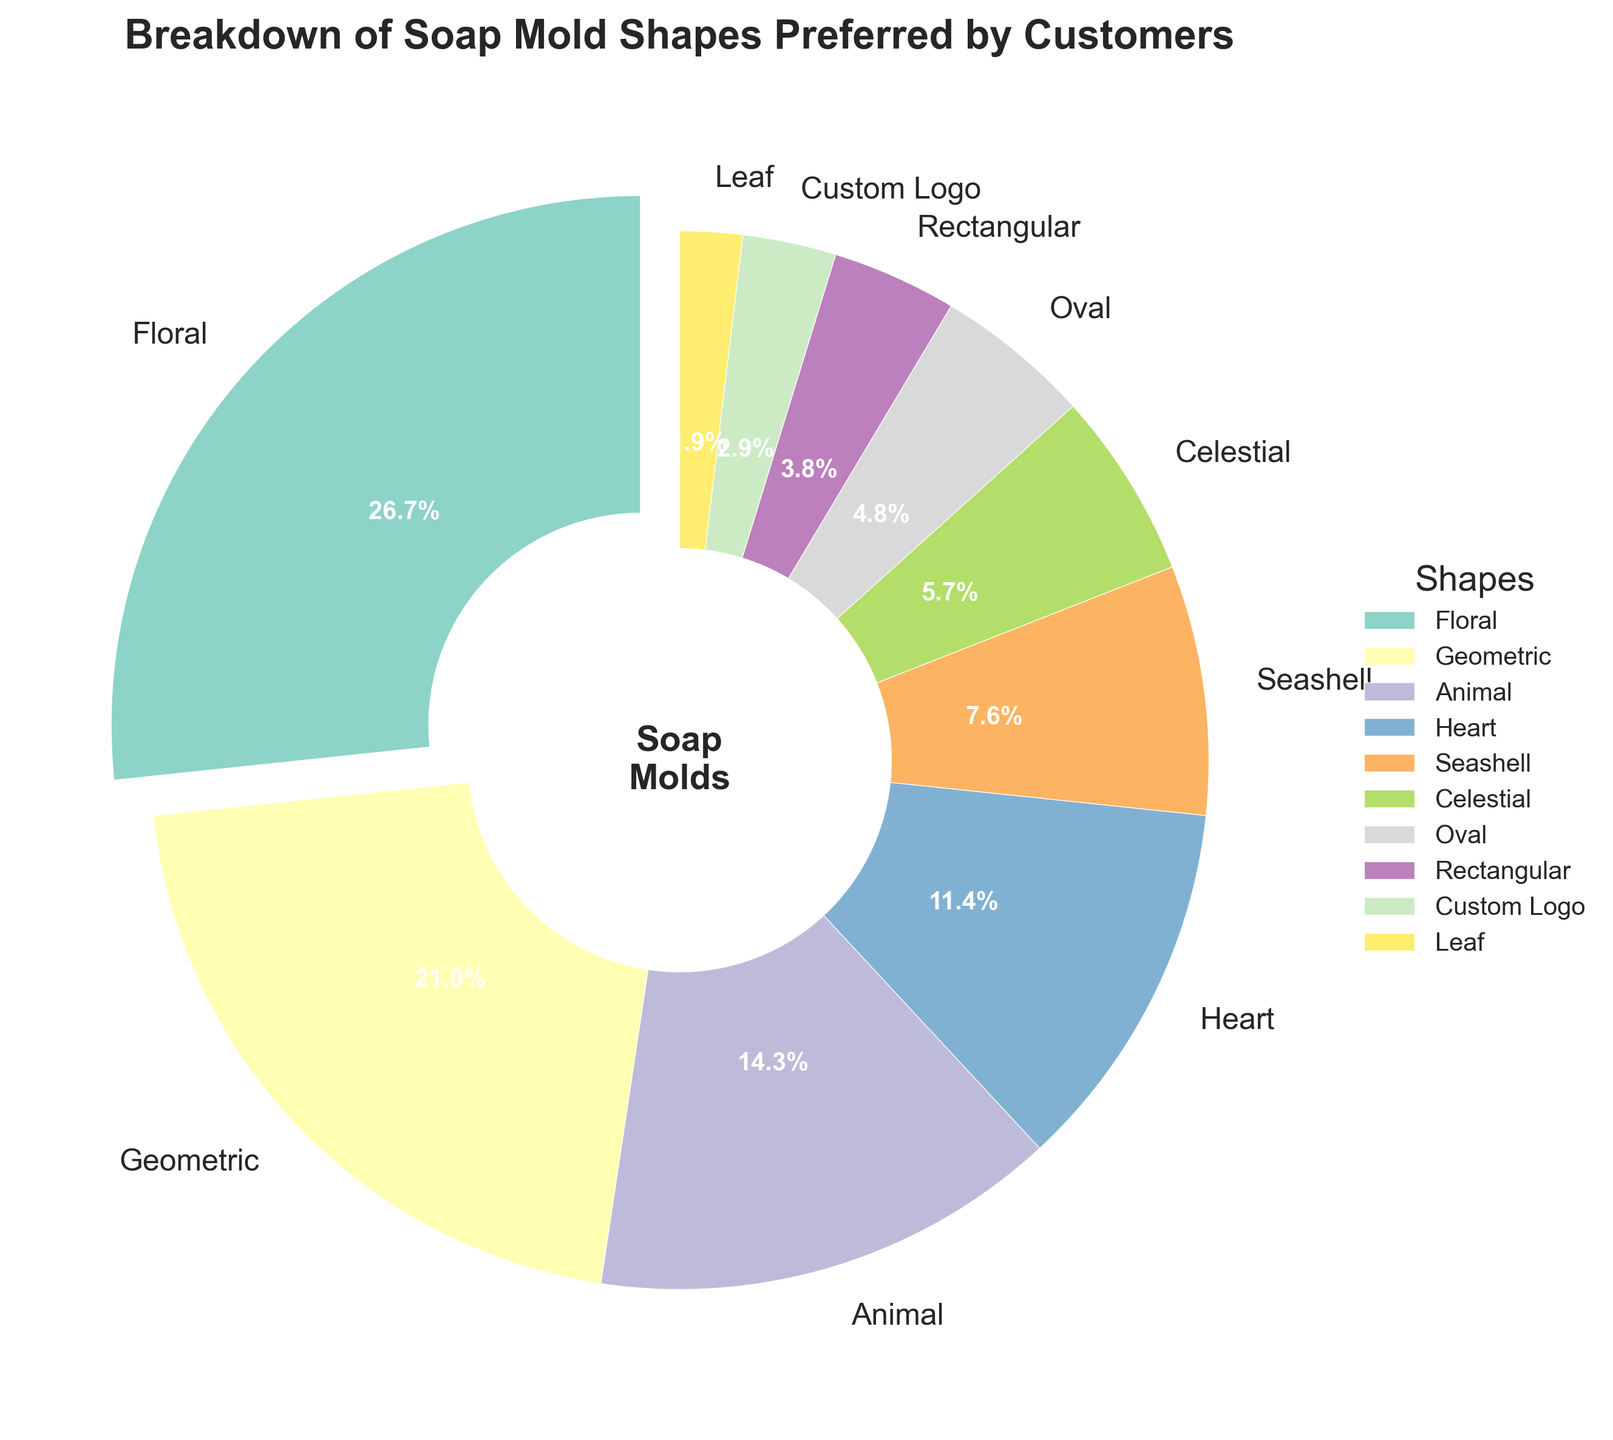Which soap mold shape is the most preferred by customers? The figure shows that the "Floral" shape has the largest slice of the pie chart, along with an exploded wedge for emphasis. This indicates it is the most preferred.
Answer: Floral Which two soap mold shapes have an equal percentage of preference? By observing the pie chart and the percentages, it's clear that no two shapes have exactly the same percentage of preference.
Answer: None Which mold shape category has a higher preference: Heart or Animal? The pie chart shows that "Animal" has a percentage of 15%, while "Heart" has a percentage of 12%. Therefore, "Animal" is more preferred.
Answer: Animal What is the combined percentage of the least three preferred soap mold shapes? According to the chart, the least three preferred shapes are "Rectangular" (4%), "Custom Logo" (3%), and "Leaf" (2%). Summing these up: 4% + 3% + 2% = 9%.
Answer: 9% How much more preferred is the "Celestial" shape compared to the "Oval" shape? The chart indicates that "Celestial" has a 6% preference and "Oval" has a 5% preference. The difference is 6% - 5% = 1%.
Answer: 1% What percentage of customers prefers geometric mold shapes? By looking at the pie chart, the "Geometric" shape is directly labeled with 22%.
Answer: 22% Which mold shape has the smallest preference and what is its percentage? The chart shows that "Leaf" is the smallest slice with a label of 2%.
Answer: Leaf, 2% Out of the four most preferred shapes, which one has the lowest percentage? The four most preferred shapes by percentage are "Floral" (28%), "Geometric" (22%), "Animal" (15%), and "Heart" (12%). "Heart" has the lowest among these.
Answer: Heart How does the preference for "Heart" shape compare to the total percentage of "Seashell" and "Oval" shapes combined? The "Heart" shape has a preference of 12%. "Seashell" has 8% and "Oval" has 5%. Combined, they have 8% + 5% = 13%. So, "Heart" has a 1% lower preference than the combined "Seashell" and "Oval".
Answer: 1% lower What's the visual color representation used for the "Custom Logo" soap mold shape? In the pie chart, the "Custom Logo" section is identified by a specific color. By looking at the legend, we can see the specific color assigned for "Custom Logo".
Answer: Check the legend for the exact color (not specified here) 